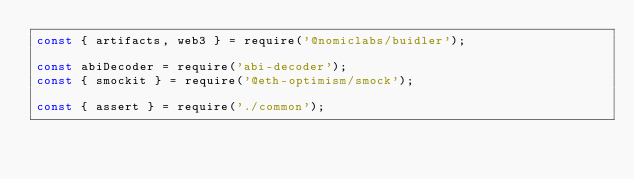Convert code to text. <code><loc_0><loc_0><loc_500><loc_500><_JavaScript_>const { artifacts, web3 } = require('@nomiclabs/buidler');

const abiDecoder = require('abi-decoder');
const { smockit } = require('@eth-optimism/smock');

const { assert } = require('./common');
</code> 